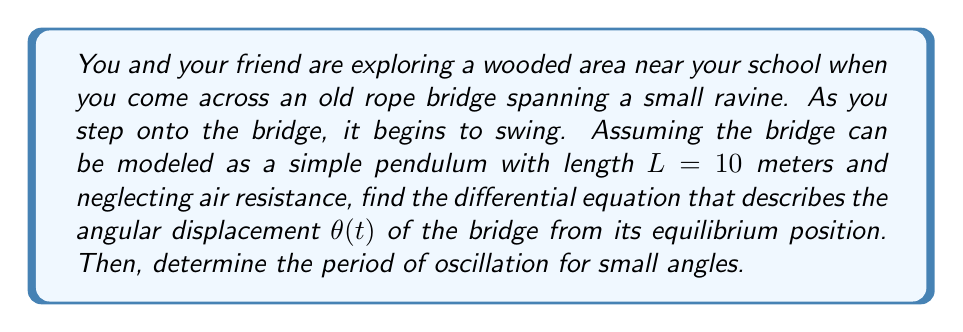Help me with this question. 1) The motion of a simple pendulum is governed by Newton's second law of motion. The tangential component of the gravitational force provides the restoring force.

2) The equation of motion for a simple pendulum is:

   $$\frac{d^2\theta}{dt^2} + \frac{g}{L}\sin\theta = 0$$

   where $g$ is the acceleration due to gravity (approximately 9.8 m/s²), $L$ is the length of the pendulum, and $\theta$ is the angular displacement.

3) This is the differential equation that describes the angular displacement $\theta(t)$ of the bridge.

4) For small angles, $\sin\theta \approx \theta$ (in radians). This approximation simplifies the equation to:

   $$\frac{d^2\theta}{dt^2} + \frac{g}{L}\theta = 0$$

5) This is a simple harmonic oscillator equation with angular frequency $\omega = \sqrt{\frac{g}{L}}$.

6) The period of oscillation $T$ is given by:

   $$T = \frac{2\pi}{\omega} = 2\pi\sqrt{\frac{L}{g}}$$

7) Substituting the given values:

   $$T = 2\pi\sqrt{\frac{10}{9.8}} \approx 6.34 \text{ seconds}$$
Answer: Differential equation: $\frac{d^2\theta}{dt^2} + \frac{g}{L}\sin\theta = 0$; Period: $6.34$ seconds 